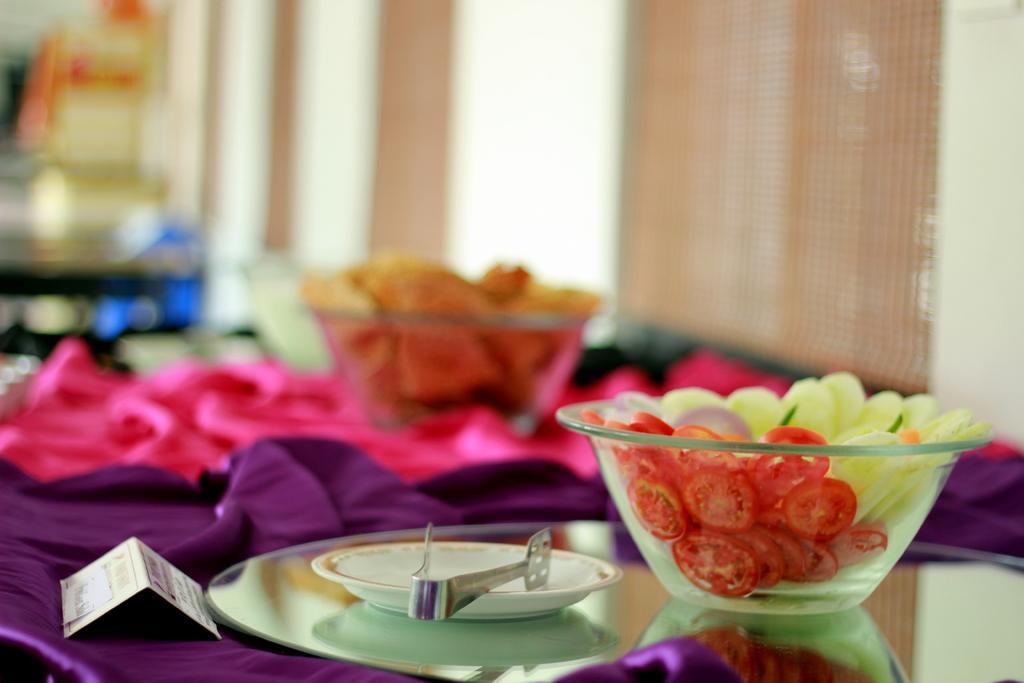Describe this image in one or two sentences. In this image there are some food items served in the bowls and the bowls are on the table, on the table there are two plates, a utensil and tablecloths, behind the table it may be curtain clothes. 